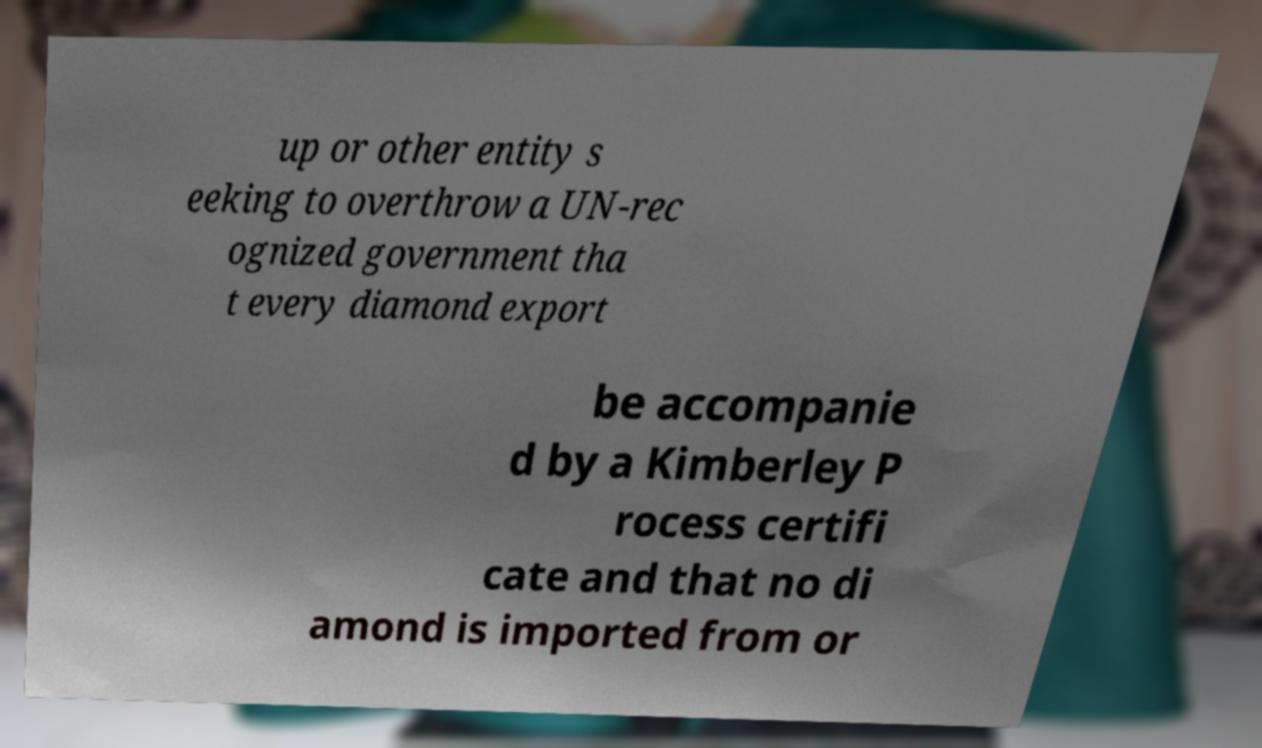Can you read and provide the text displayed in the image?This photo seems to have some interesting text. Can you extract and type it out for me? up or other entity s eeking to overthrow a UN-rec ognized government tha t every diamond export be accompanie d by a Kimberley P rocess certifi cate and that no di amond is imported from or 